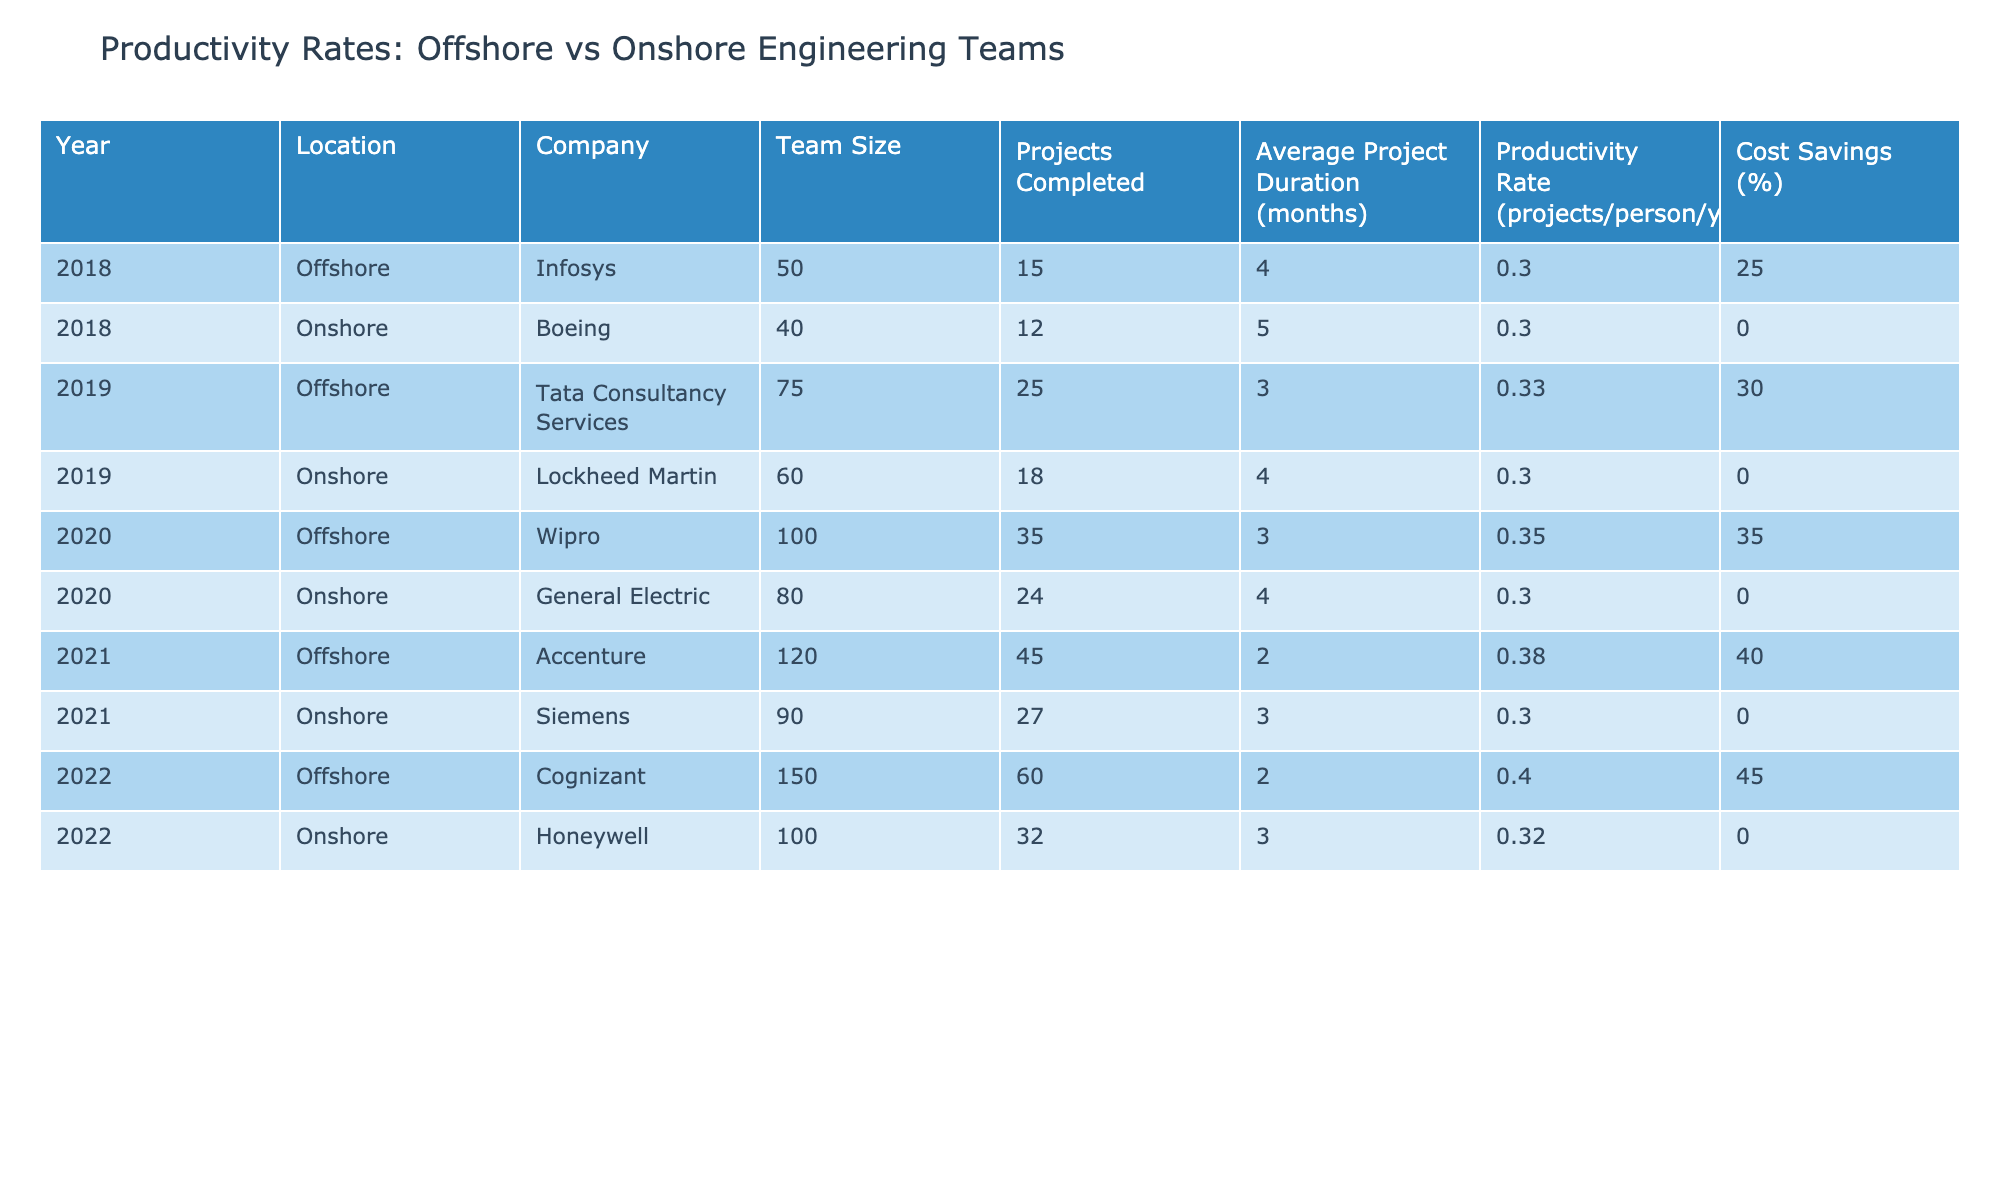What was the productivity rate of the offshore team in 2020? Looking at the table, in the year 2020, the productivity rate for the offshore team is listed as 0.35 projects per person per year.
Answer: 0.35 How many projects were completed by the onshore team in 2021? By checking the 2021 row for the onshore team, it shows that 27 projects were completed by Siemens.
Answer: 27 What is the average productivity rate for the onshore teams over the 5-year period? First, we note the productivity rates for the onshore teams: (0.3, 0.3, 0.3, 0.32). Adding these gives 1.22, and dividing by the number of years (4) results in an average of 0.305.
Answer: 0.305 Was the productivity rate of the offshore team higher than 0.35 in any year? Looking at the offshore productivity rates, we can see that they were 0.3 (2018), 0.33 (2019), 0.35 (2020), 0.38 (2021), and 0.4 (2022). Therefore, it was higher than 0.35 in 2021 and 2022.
Answer: Yes What years did the offshore team show the greatest cost savings, and what were those percentages? By examining the cost savings for the offshore teams, we see the following percentages: 25% (2018), 30% (2019), 35% (2020), 40% (2021), and 45% (2022). Therefore, the greatest cost saving was in 2022 at 45%.
Answer: 2022, 45% Which offshore team completed the most projects, and how many were completed? Referring to the offshore teams, Cognizant completed the most projects: 60 in the year 2022.
Answer: Cognizant, 60 Did the onshore teams complete more projects than the offshore teams in 2019? In 2019, the offshore team completed 25 projects, while the onshore team completed 18 projects. The onshore team did not complete more projects than the offshore team.
Answer: No What was the trend of productivity rates for offshore teams from 2018 to 2022? The productivity rates for offshore teams were: 0.3 (2018) to 0.33 (2019), then to 0.35 (2020), rising to 0.38 (2021), and finally 0.4 (2022). This shows a general upward trend.
Answer: Upward trend What was the total number of projects completed by offshore teams over the 5 years? Summing the projects completed: 15 (2018) + 25 (2019) + 35 (2020) + 45 (2021) + 60 (2022) equals 180.
Answer: 180 Which year saw the highest productivity rate for onshore teams, and what was that rate? The productivity rates for the onshore teams show 0.3 for 2018, 2019, and 2020, 0.32 for 2022. The highest was 0.32 in 2022.
Answer: 2022, 0.32 